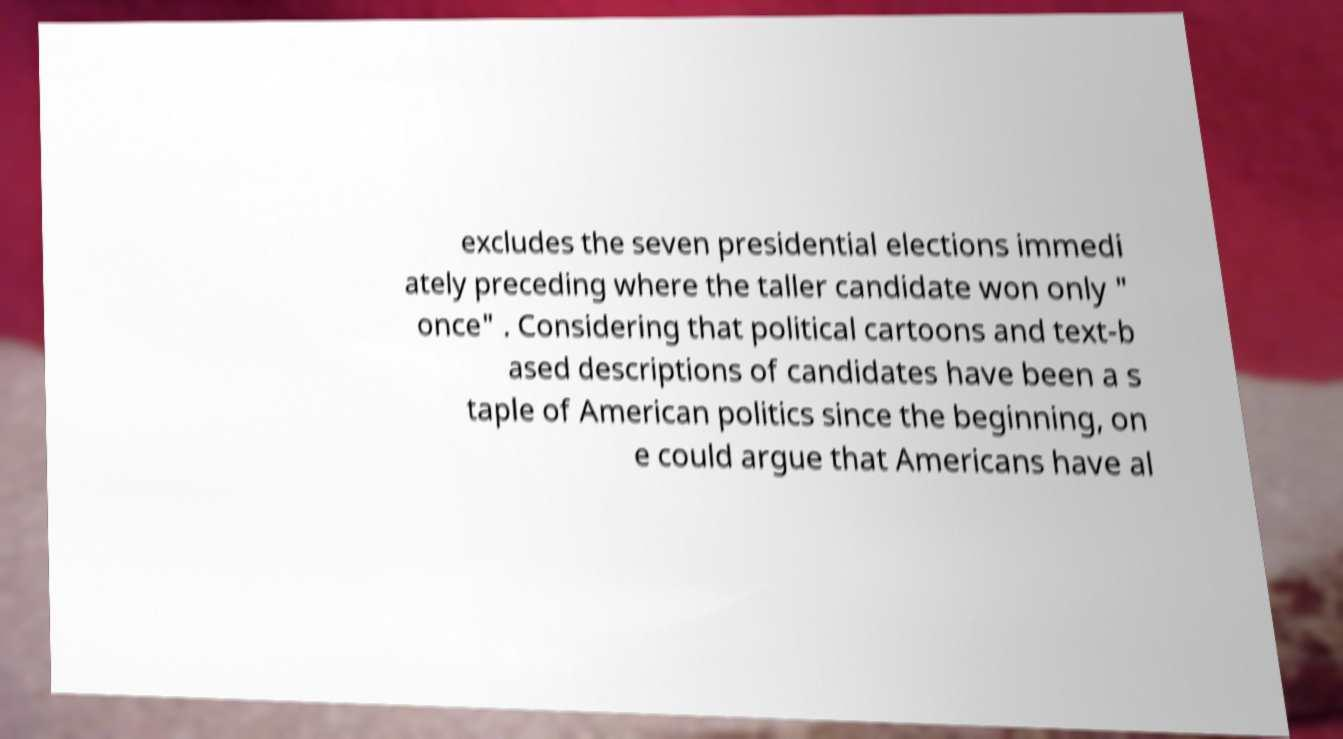For documentation purposes, I need the text within this image transcribed. Could you provide that? excludes the seven presidential elections immedi ately preceding where the taller candidate won only " once" . Considering that political cartoons and text-b ased descriptions of candidates have been a s taple of American politics since the beginning, on e could argue that Americans have al 